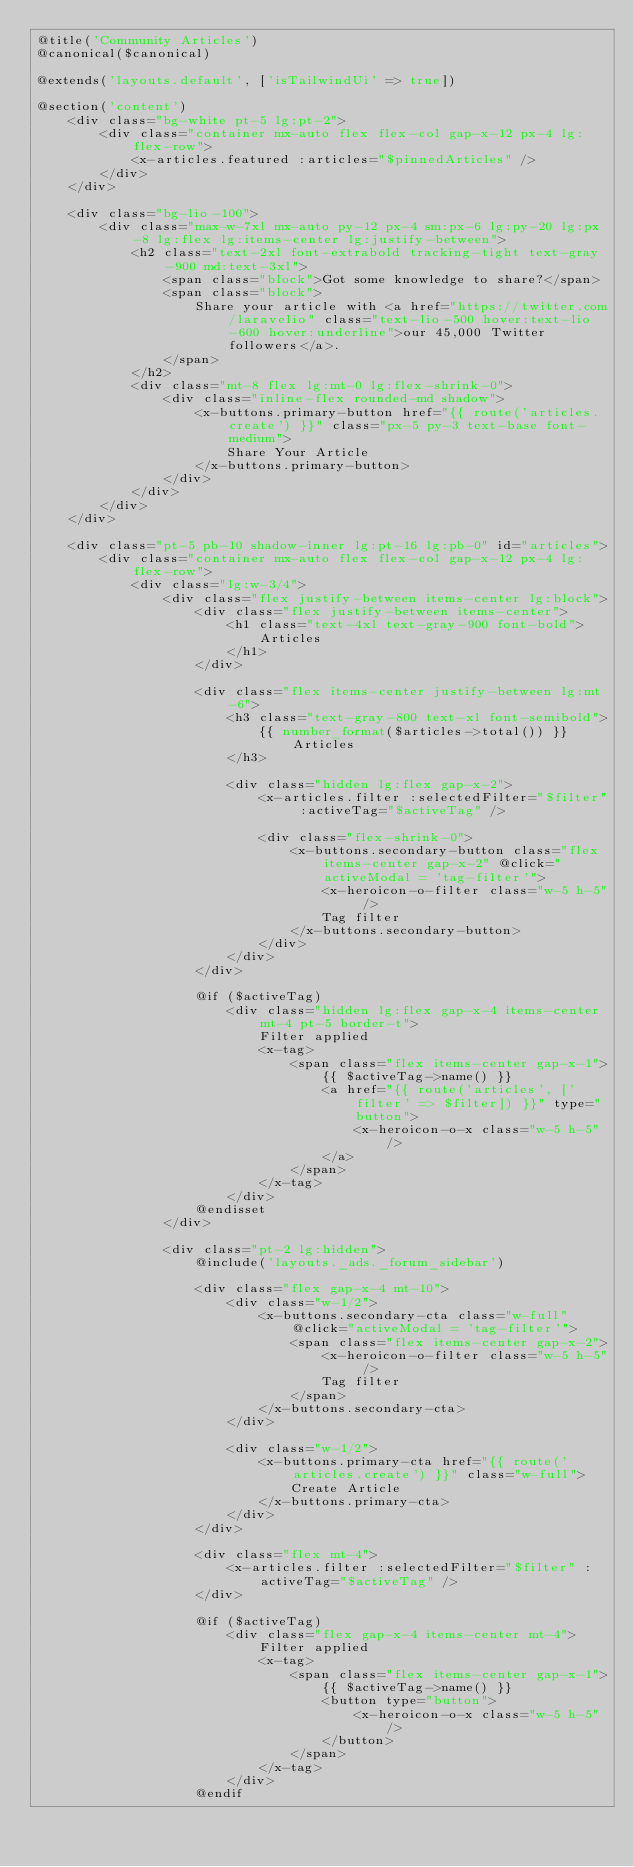<code> <loc_0><loc_0><loc_500><loc_500><_PHP_>@title('Community Articles')
@canonical($canonical)

@extends('layouts.default', ['isTailwindUi' => true])

@section('content')
    <div class="bg-white pt-5 lg:pt-2">
        <div class="container mx-auto flex flex-col gap-x-12 px-4 lg:flex-row">
            <x-articles.featured :articles="$pinnedArticles" />
        </div>
    </div>

    <div class="bg-lio-100">
        <div class="max-w-7xl mx-auto py-12 px-4 sm:px-6 lg:py-20 lg:px-8 lg:flex lg:items-center lg:justify-between">
            <h2 class="text-2xl font-extrabold tracking-tight text-gray-900 md:text-3xl">
                <span class="block">Got some knowledge to share?</span>
                <span class="block">
                    Share your article with <a href="https://twitter.com/laravelio" class="text-lio-500 hover:text-lio-600 hover:underline">our 45,000 Twitter followers</a>.
                </span>
            </h2>
            <div class="mt-8 flex lg:mt-0 lg:flex-shrink-0">
                <div class="inline-flex rounded-md shadow">
                    <x-buttons.primary-button href="{{ route('articles.create') }}" class="px-5 py-3 text-base font-medium">
                        Share Your Article
                    </x-buttons.primary-button>
                </div>
            </div>
        </div>
    </div>

    <div class="pt-5 pb-10 shadow-inner lg:pt-16 lg:pb-0" id="articles">
        <div class="container mx-auto flex flex-col gap-x-12 px-4 lg:flex-row">
            <div class="lg:w-3/4">
                <div class="flex justify-between items-center lg:block">
                    <div class="flex justify-between items-center">
                        <h1 class="text-4xl text-gray-900 font-bold">
                            Articles
                        </h1>
                    </div>

                    <div class="flex items-center justify-between lg:mt-6">
                        <h3 class="text-gray-800 text-xl font-semibold">
                            {{ number_format($articles->total()) }} Articles
                        </h3>

                        <div class="hidden lg:flex gap-x-2">
                            <x-articles.filter :selectedFilter="$filter" :activeTag="$activeTag" />

                            <div class="flex-shrink-0">
                                <x-buttons.secondary-button class="flex items-center gap-x-2" @click="activeModal = 'tag-filter'">
                                    <x-heroicon-o-filter class="w-5 h-5" />
                                    Tag filter
                                </x-buttons.secondary-button>
                            </div>
                        </div>
                    </div>

                    @if ($activeTag)
                        <div class="hidden lg:flex gap-x-4 items-center mt-4 pt-5 border-t">
                            Filter applied
                            <x-tag>
                                <span class="flex items-center gap-x-1">
                                    {{ $activeTag->name() }}
                                    <a href="{{ route('articles', ['filter' => $filter]) }}" type="button">
                                        <x-heroicon-o-x class="w-5 h-5" />
                                    </a>
                                </span>
                            </x-tag>
                        </div>
                    @endisset
                </div>

                <div class="pt-2 lg:hidden">
                    @include('layouts._ads._forum_sidebar')

                    <div class="flex gap-x-4 mt-10">
                        <div class="w-1/2">
                            <x-buttons.secondary-cta class="w-full" @click="activeModal = 'tag-filter'">
                                <span class="flex items-center gap-x-2">
                                    <x-heroicon-o-filter class="w-5 h-5" />
                                    Tag filter
                                </span>
                            </x-buttons.secondary-cta>
                        </div>

                        <div class="w-1/2">
                            <x-buttons.primary-cta href="{{ route('articles.create') }}" class="w-full">
                                Create Article
                            </x-buttons.primary-cta>
                        </div>
                    </div>

                    <div class="flex mt-4">
                        <x-articles.filter :selectedFilter="$filter" :activeTag="$activeTag" />
                    </div>

                    @if ($activeTag)
                        <div class="flex gap-x-4 items-center mt-4">
                            Filter applied
                            <x-tag>
                                <span class="flex items-center gap-x-1">
                                    {{ $activeTag->name() }}
                                    <button type="button">
                                        <x-heroicon-o-x class="w-5 h-5" />
                                    </button>
                                </span>
                            </x-tag>
                        </div>
                    @endif</code> 